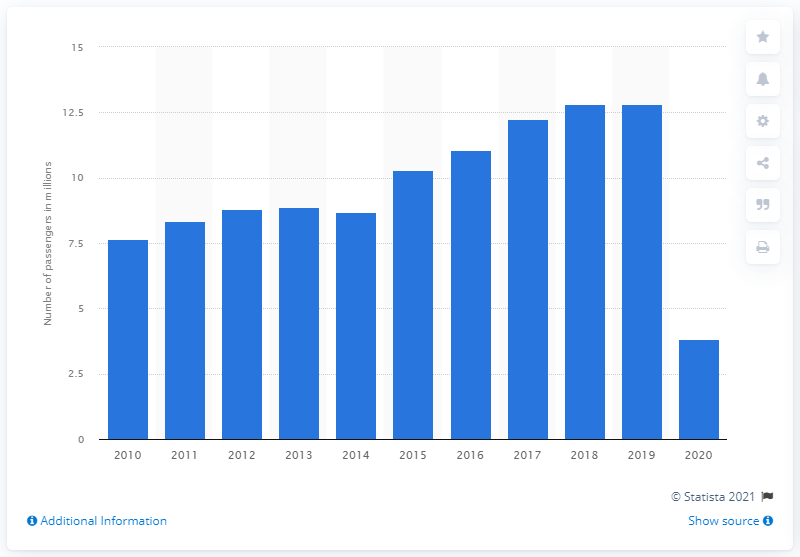List a handful of essential elements in this visual. In 2020, a total of 3,830 passengers traveled via Bergamo Orio al Serio Airport. In 2019, a total of 12,800 passengers traveled via Bergamo Orio al Serio Airport. 